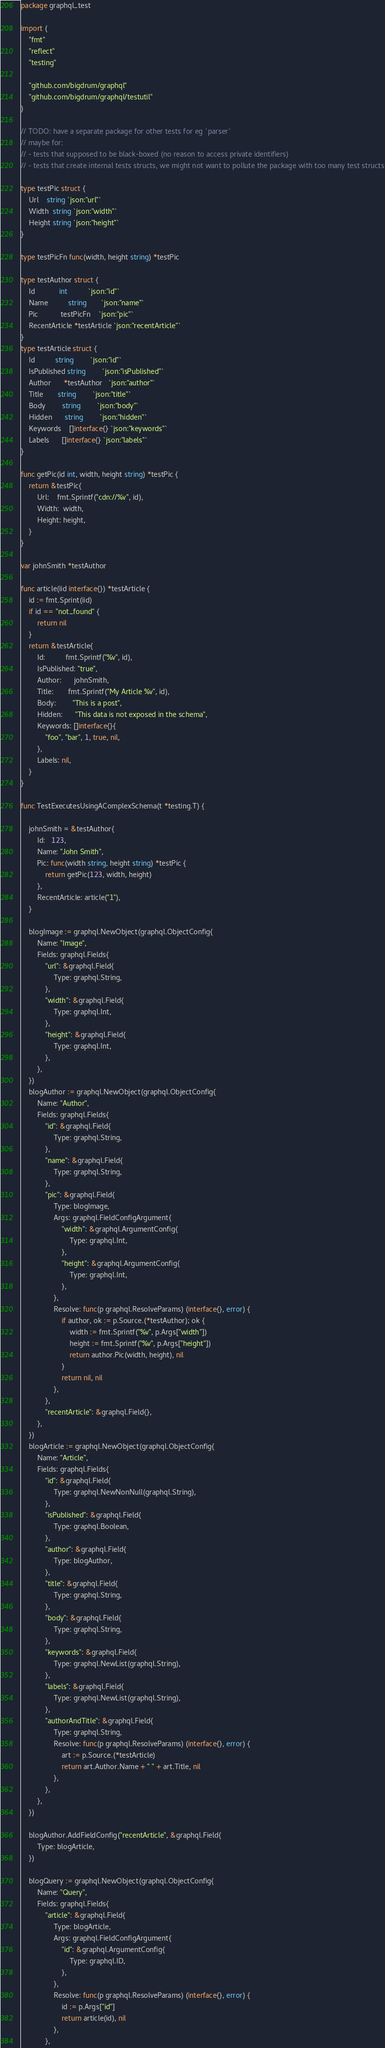Convert code to text. <code><loc_0><loc_0><loc_500><loc_500><_Go_>package graphql_test

import (
	"fmt"
	"reflect"
	"testing"

	"github.com/bigdrum/graphql"
	"github.com/bigdrum/graphql/testutil"
)

// TODO: have a separate package for other tests for eg `parser`
// maybe for:
// - tests that supposed to be black-boxed (no reason to access private identifiers)
// - tests that create internal tests structs, we might not want to pollute the package with too many test structs

type testPic struct {
	Url    string `json:"url"`
	Width  string `json:"width"`
	Height string `json:"height"`
}

type testPicFn func(width, height string) *testPic

type testAuthor struct {
	Id            int          `json:"id"`
	Name          string       `json:"name"`
	Pic           testPicFn    `json:"pic"`
	RecentArticle *testArticle `json:"recentArticle"`
}
type testArticle struct {
	Id          string        `json:"id"`
	IsPublished string        `json:"isPublished"`
	Author      *testAuthor   `json:"author"`
	Title       string        `json:"title"`
	Body        string        `json:"body"`
	Hidden      string        `json:"hidden"`
	Keywords    []interface{} `json:"keywords"`
	Labels      []interface{} `json:"labels"`
}

func getPic(id int, width, height string) *testPic {
	return &testPic{
		Url:    fmt.Sprintf("cdn://%v", id),
		Width:  width,
		Height: height,
	}
}

var johnSmith *testAuthor

func article(iid interface{}) *testArticle {
	id := fmt.Sprint(iid)
	if id == "not_found" {
		return nil
	}
	return &testArticle{
		Id:          fmt.Sprintf("%v", id),
		IsPublished: "true",
		Author:      johnSmith,
		Title:       fmt.Sprintf("My Article %v", id),
		Body:        "This is a post",
		Hidden:      "This data is not exposed in the schema",
		Keywords: []interface{}{
			"foo", "bar", 1, true, nil,
		},
		Labels: nil,
	}
}

func TestExecutesUsingAComplexSchema(t *testing.T) {

	johnSmith = &testAuthor{
		Id:   123,
		Name: "John Smith",
		Pic: func(width string, height string) *testPic {
			return getPic(123, width, height)
		},
		RecentArticle: article("1"),
	}

	blogImage := graphql.NewObject(graphql.ObjectConfig{
		Name: "Image",
		Fields: graphql.Fields{
			"url": &graphql.Field{
				Type: graphql.String,
			},
			"width": &graphql.Field{
				Type: graphql.Int,
			},
			"height": &graphql.Field{
				Type: graphql.Int,
			},
		},
	})
	blogAuthor := graphql.NewObject(graphql.ObjectConfig{
		Name: "Author",
		Fields: graphql.Fields{
			"id": &graphql.Field{
				Type: graphql.String,
			},
			"name": &graphql.Field{
				Type: graphql.String,
			},
			"pic": &graphql.Field{
				Type: blogImage,
				Args: graphql.FieldConfigArgument{
					"width": &graphql.ArgumentConfig{
						Type: graphql.Int,
					},
					"height": &graphql.ArgumentConfig{
						Type: graphql.Int,
					},
				},
				Resolve: func(p graphql.ResolveParams) (interface{}, error) {
					if author, ok := p.Source.(*testAuthor); ok {
						width := fmt.Sprintf("%v", p.Args["width"])
						height := fmt.Sprintf("%v", p.Args["height"])
						return author.Pic(width, height), nil
					}
					return nil, nil
				},
			},
			"recentArticle": &graphql.Field{},
		},
	})
	blogArticle := graphql.NewObject(graphql.ObjectConfig{
		Name: "Article",
		Fields: graphql.Fields{
			"id": &graphql.Field{
				Type: graphql.NewNonNull(graphql.String),
			},
			"isPublished": &graphql.Field{
				Type: graphql.Boolean,
			},
			"author": &graphql.Field{
				Type: blogAuthor,
			},
			"title": &graphql.Field{
				Type: graphql.String,
			},
			"body": &graphql.Field{
				Type: graphql.String,
			},
			"keywords": &graphql.Field{
				Type: graphql.NewList(graphql.String),
			},
			"labels": &graphql.Field{
				Type: graphql.NewList(graphql.String),
			},
			"authorAndTitle": &graphql.Field{
				Type: graphql.String,
				Resolve: func(p graphql.ResolveParams) (interface{}, error) {
					art := p.Source.(*testArticle)
					return art.Author.Name + " " + art.Title, nil
				},
			},
		},
	})

	blogAuthor.AddFieldConfig("recentArticle", &graphql.Field{
		Type: blogArticle,
	})

	blogQuery := graphql.NewObject(graphql.ObjectConfig{
		Name: "Query",
		Fields: graphql.Fields{
			"article": &graphql.Field{
				Type: blogArticle,
				Args: graphql.FieldConfigArgument{
					"id": &graphql.ArgumentConfig{
						Type: graphql.ID,
					},
				},
				Resolve: func(p graphql.ResolveParams) (interface{}, error) {
					id := p.Args["id"]
					return article(id), nil
				},
			},</code> 